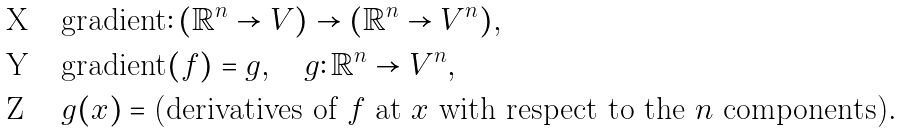Convert formula to latex. <formula><loc_0><loc_0><loc_500><loc_500>& \text {gradient} \colon ( \mathbb { R } ^ { n } \to V ) \to ( \mathbb { R } ^ { n } \to V ^ { n } ) , \\ & \text {gradient} ( f ) = g , \quad g \colon \mathbb { R } ^ { n } \to V ^ { n } , \\ & g ( x ) = \text {(derivatives of $f$ at $x$ with respect to the $n$ components)} .</formula> 